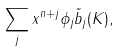<formula> <loc_0><loc_0><loc_500><loc_500>\sum _ { j } x ^ { n + j } \phi _ { j } \tilde { b } _ { j } ( K ) ,</formula> 